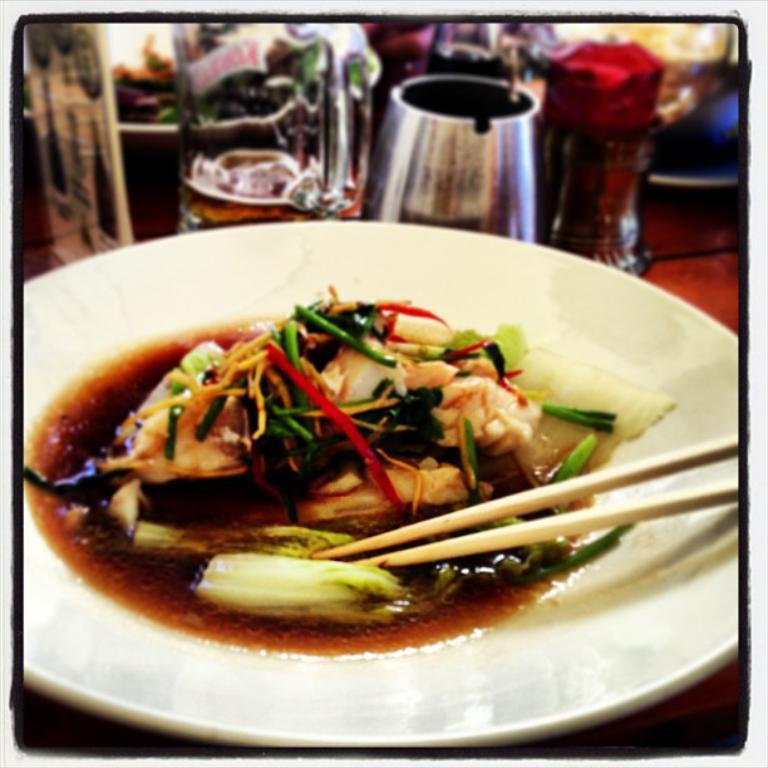What is located on the platter in the foreground of the image? There is food on a platter in the foreground of the image. What utensils are present with the food on the platter? There are two chopsticks on the platter. What can be seen in the background of the image? There is a jar and a bottle in the background of the image. Can you describe the unclear objects on the table in the background? Unfortunately, the objects on the table in the background are unclear and cannot be described in detail. What type of wood is used to make the representative clocks in the image? There are no representative clocks present in the image, so it is not possible to determine the type of wood used to make them. 